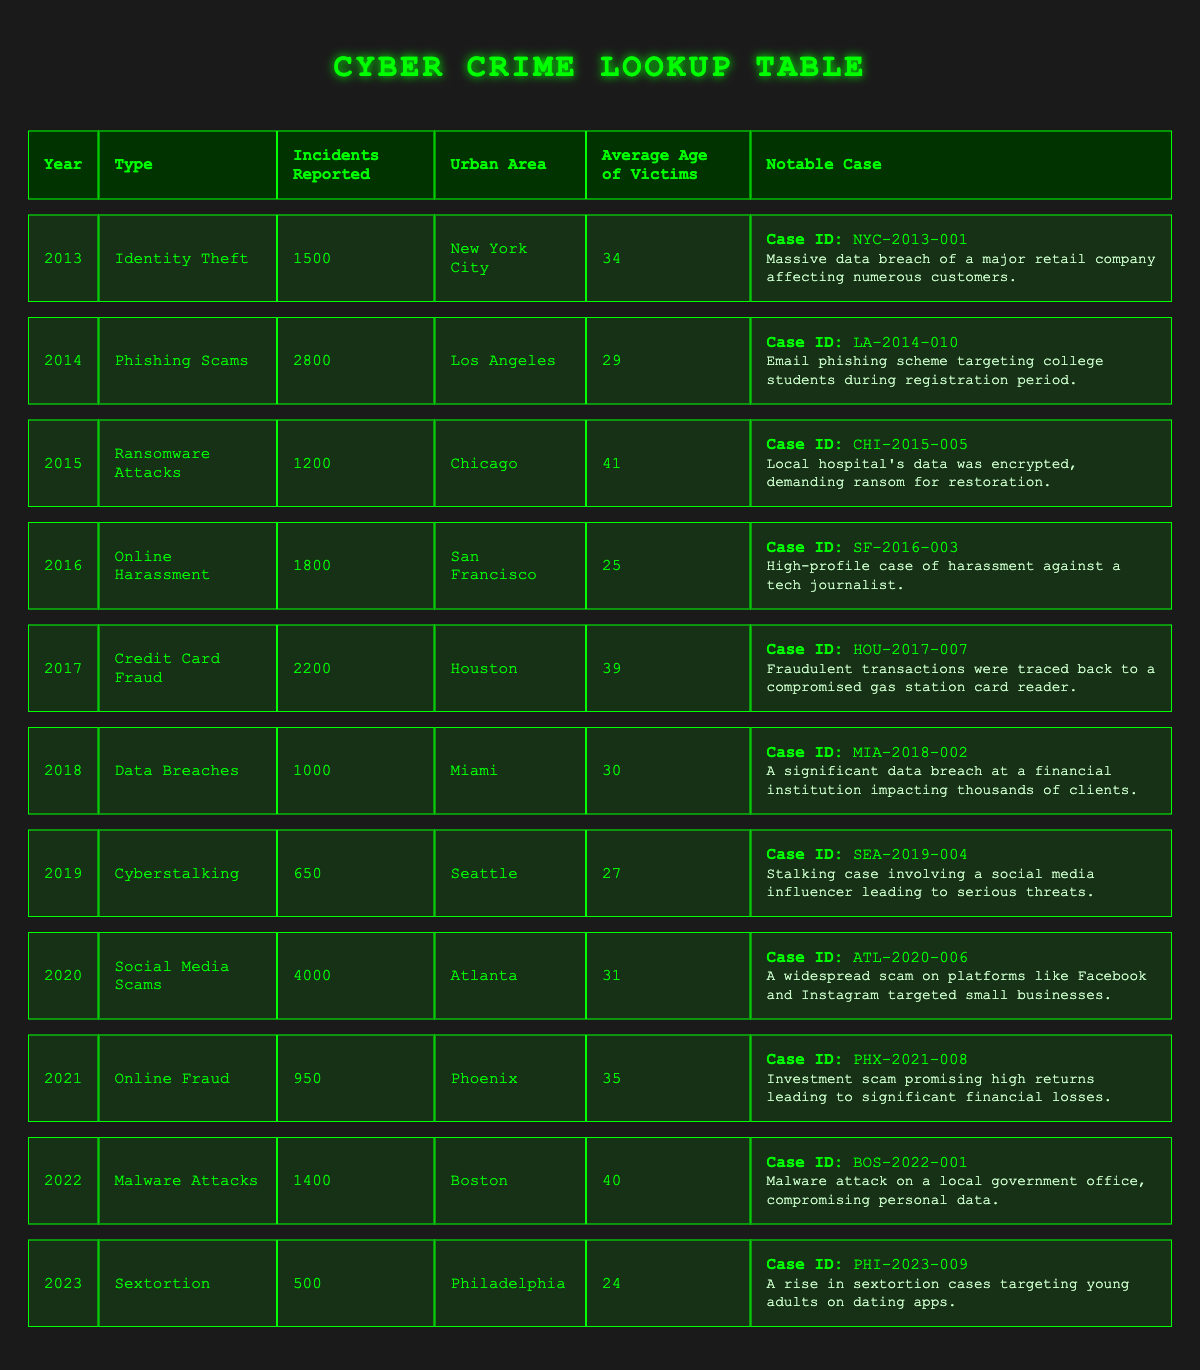What was the most reported type of cyber crime in 2020? In 2020, Social Media Scams had the highest incidents reported with a total of 4000. This can be directly observed from the table under the year 2020 in the "Incidents Reported" column.
Answer: Social Media Scams Which urban area had the least incidents reported in 2019? In 2019, Seattle reported the least incidents with 650 incidents of Cyberstalking. This is confirmed by looking at the "Urban Area" and "Incidents Reported" columns for that year.
Answer: Seattle What is the average age of victims across all types of crimes reported in 2023? To find the average age of victims in 2023, we only have one entry for that year which is 24 years old for the incident of Sextortion. Therefore, the average age is simply 24.
Answer: 24 Is there a notable case associated with the ransomware attacks in 2015? Yes, there is a notable case listed for ransomware attacks in 2015, specifically case ID CHI-2015-005. The case involved a local hospital's data being encrypted and a ransom demanded for restoration. This is clearly indicated in the corresponding row of the table.
Answer: Yes What is the total number of incidents reported for Malware Attacks and Online Fraud combined? To find the total number of incidents reported for both Malware Attacks (1400) and Online Fraud (950), we add these two numbers: 1400 + 950 = 2350. This requires checking both rows for the respective years and summing them up.
Answer: 2350 Which type of cyber crime reported the highest average age of victims and what was that age? The type of cyber crime with the highest average age of victims is Ransomware Attacks from 2015, where the average age of victims is 41. This information is derived from the average age column in that row.
Answer: Ransomware Attacks, 41 Was there an increase or decrease in reported incidents of Cyber Crime from 2018 to 2020? There was an increase in reported incidents from 2018 (1000 incidents of Data Breaches) to 2020 (4000 incidents of Social Media Scams). This is determined by comparing the incidents reported in those two specific years.
Answer: Increase How many more incidents of Cyber Crimes were reported in Los Angeles compared to Miami in 2014 and 2018 respectively? In 2014, Los Angeles reported 2800 incidents of Phishing Scams while Miami reported 1000 incidents in 2018. The difference is calculated as 2800 - 1000 = 1800 incidents, indicating that Los Angeles had significantly more incidents than Miami.
Answer: 1800 